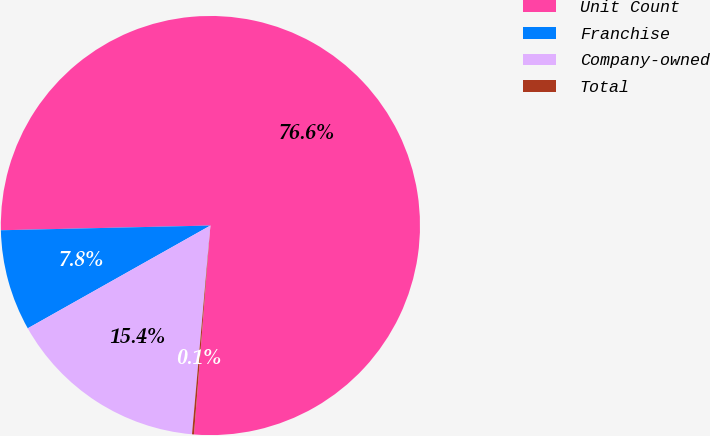Convert chart. <chart><loc_0><loc_0><loc_500><loc_500><pie_chart><fcel>Unit Count<fcel>Franchise<fcel>Company-owned<fcel>Total<nl><fcel>76.61%<fcel>7.8%<fcel>15.44%<fcel>0.15%<nl></chart> 